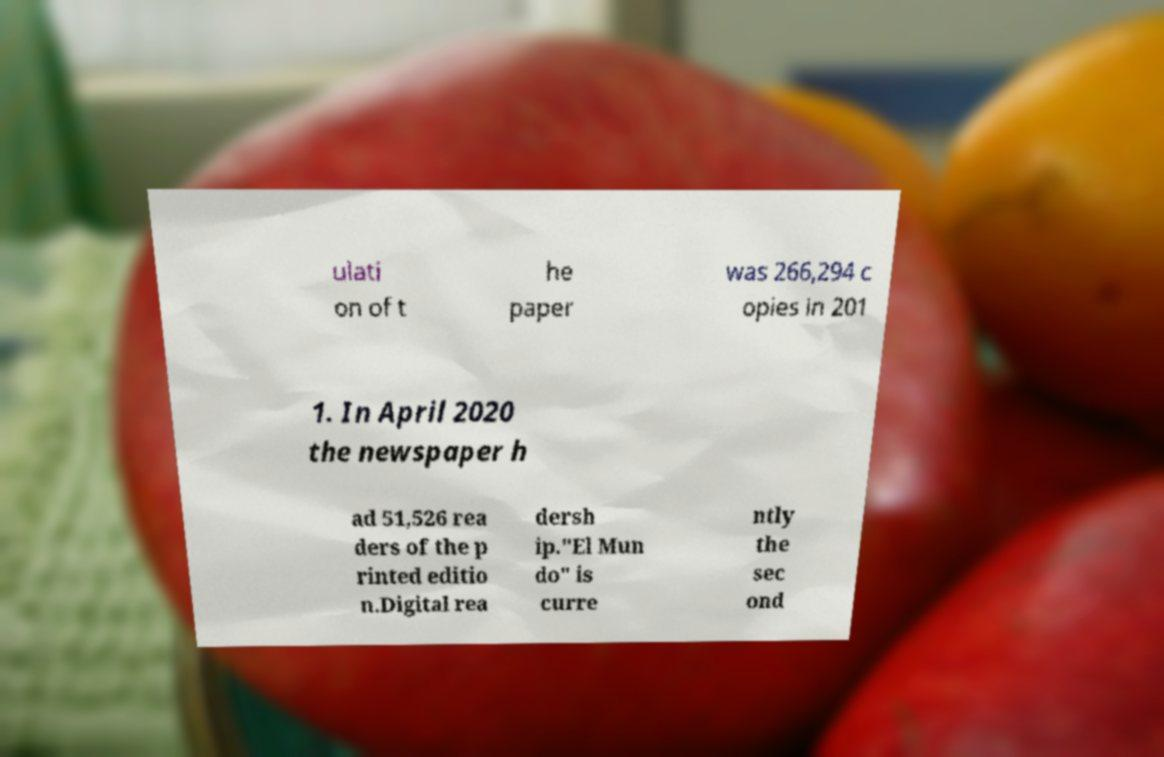Could you extract and type out the text from this image? ulati on of t he paper was 266,294 c opies in 201 1. In April 2020 the newspaper h ad 51,526 rea ders of the p rinted editio n.Digital rea dersh ip."El Mun do" is curre ntly the sec ond 